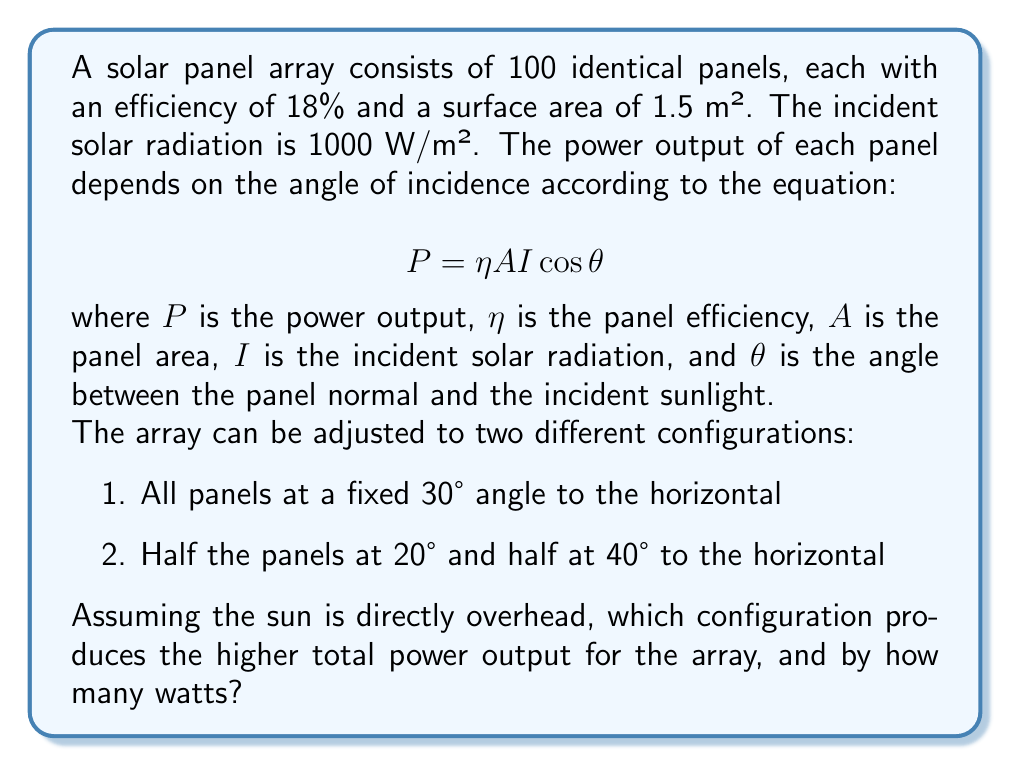Could you help me with this problem? Let's approach this step-by-step:

1) First, we need to calculate the power output for a single panel at different angles:

   For a panel at angle $\theta$ to the horizontal, the angle to the sun (which is directly overhead) is $(90° - \theta)$.

   $$P = \eta A I \cos(90° - \theta) = \eta A I \sin\theta$$

2) Let's plug in the known values:
   $\eta = 0.18$
   $A = 1.5$ m²
   $I = 1000$ W/m²

   So our equation becomes:
   $$P = 0.18 \times 1.5 \times 1000 \times \sin\theta = 270 \sin\theta \text{ watts}$$

3) Now let's calculate for each configuration:

   Configuration 1 (all panels at 30°):
   $$P_{30°} = 270 \sin(30°) = 270 \times 0.5 = 135 \text{ watts per panel}$$
   Total for 100 panels: $135 \times 100 = 13,500 \text{ watts}$

   Configuration 2 (half at 20°, half at 40°):
   $$P_{20°} = 270 \sin(20°) = 270 \times 0.342 = 92.34 \text{ watts per panel}$$
   $$P_{40°} = 270 \sin(40°) = 270 \times 0.643 = 173.61 \text{ watts per panel}$$
   Total for 50 panels each: $(92.34 \times 50) + (173.61 \times 50) = 13,297.5 \text{ watts}$

4) Comparing the two configurations:
   Configuration 1: 13,500 watts
   Configuration 2: 13,297.5 watts

   The difference is: $13,500 - 13,297.5 = 202.5 \text{ watts}$

Therefore, Configuration 1 (all panels at 30°) produces the higher total power output, exceeding Configuration 2 by 202.5 watts.
Answer: Configuration 1 (all panels at 30°) produces the higher total power output, exceeding Configuration 2 by 202.5 watts. 